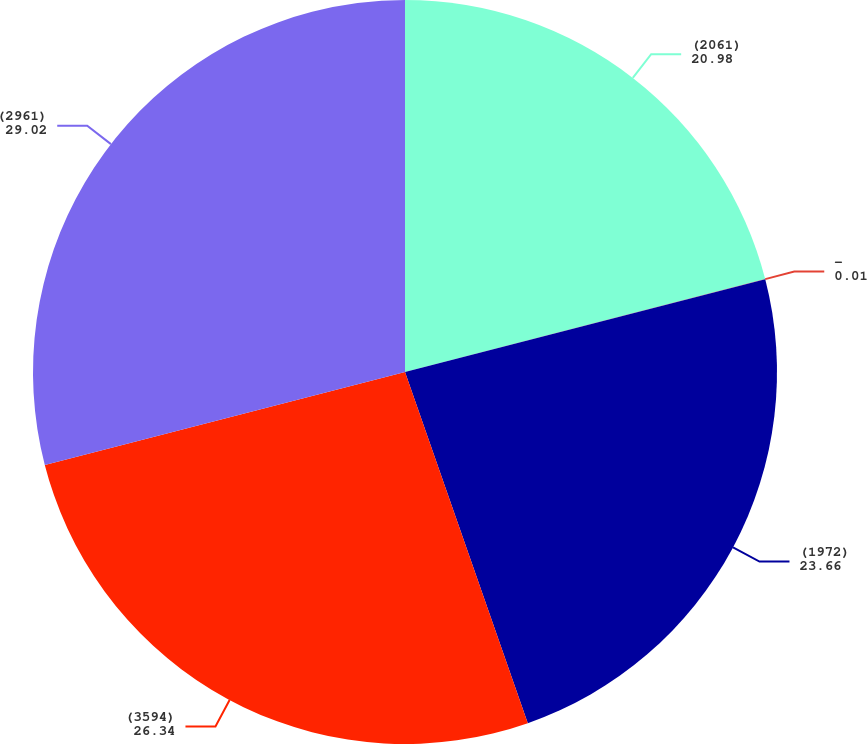Convert chart to OTSL. <chart><loc_0><loc_0><loc_500><loc_500><pie_chart><fcel>(2061)<fcel>-<fcel>(1972)<fcel>(3594)<fcel>(2961)<nl><fcel>20.98%<fcel>0.01%<fcel>23.66%<fcel>26.34%<fcel>29.02%<nl></chart> 